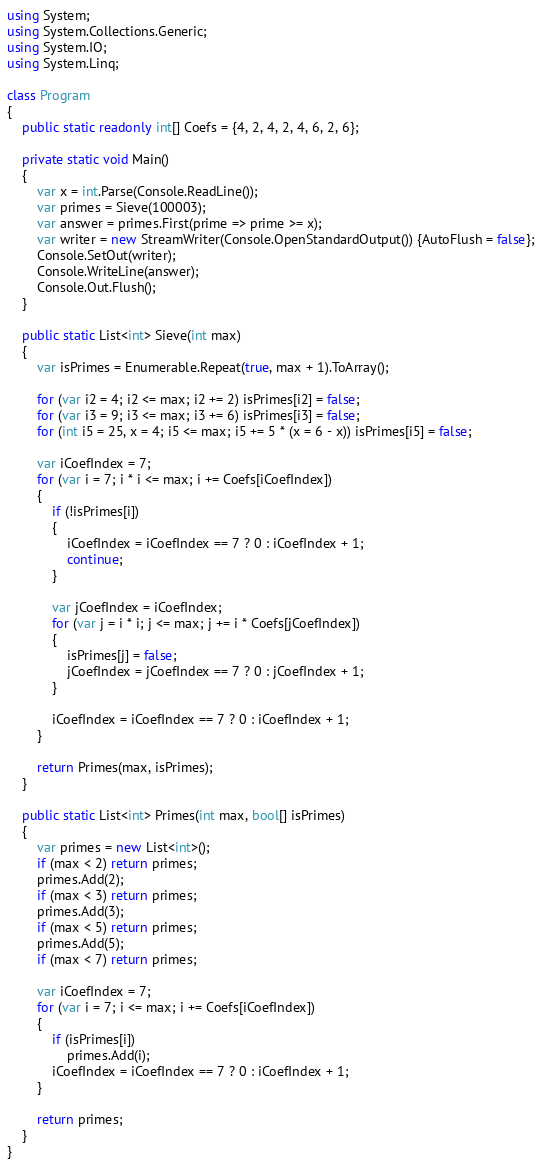Convert code to text. <code><loc_0><loc_0><loc_500><loc_500><_C#_>using System;
using System.Collections.Generic;
using System.IO;
using System.Linq;
 
class Program
{
    public static readonly int[] Coefs = {4, 2, 4, 2, 4, 6, 2, 6};
 
    private static void Main()
    {
        var x = int.Parse(Console.ReadLine());
        var primes = Sieve(100003);
        var answer = primes.First(prime => prime >= x);
        var writer = new StreamWriter(Console.OpenStandardOutput()) {AutoFlush = false};
        Console.SetOut(writer);
        Console.WriteLine(answer);
        Console.Out.Flush();
    }
 
    public static List<int> Sieve(int max)
    {
        var isPrimes = Enumerable.Repeat(true, max + 1).ToArray();
 
        for (var i2 = 4; i2 <= max; i2 += 2) isPrimes[i2] = false;
        for (var i3 = 9; i3 <= max; i3 += 6) isPrimes[i3] = false;
        for (int i5 = 25, x = 4; i5 <= max; i5 += 5 * (x = 6 - x)) isPrimes[i5] = false;
 
        var iCoefIndex = 7;
        for (var i = 7; i * i <= max; i += Coefs[iCoefIndex])
        {
            if (!isPrimes[i])
            {
                iCoefIndex = iCoefIndex == 7 ? 0 : iCoefIndex + 1;
                continue;
            }
 
            var jCoefIndex = iCoefIndex;
            for (var j = i * i; j <= max; j += i * Coefs[jCoefIndex])
            {
                isPrimes[j] = false;
                jCoefIndex = jCoefIndex == 7 ? 0 : jCoefIndex + 1;
            }
 
            iCoefIndex = iCoefIndex == 7 ? 0 : iCoefIndex + 1;
        }
 
        return Primes(max, isPrimes);
    }
 
    public static List<int> Primes(int max, bool[] isPrimes)
    {
        var primes = new List<int>();
        if (max < 2) return primes;
        primes.Add(2);
        if (max < 3) return primes;
        primes.Add(3);
        if (max < 5) return primes;
        primes.Add(5);
        if (max < 7) return primes;
 
        var iCoefIndex = 7;
        for (var i = 7; i <= max; i += Coefs[iCoefIndex])
        {
            if (isPrimes[i])
                primes.Add(i);
            iCoefIndex = iCoefIndex == 7 ? 0 : iCoefIndex + 1;
        }
 
        return primes;
    }
}</code> 